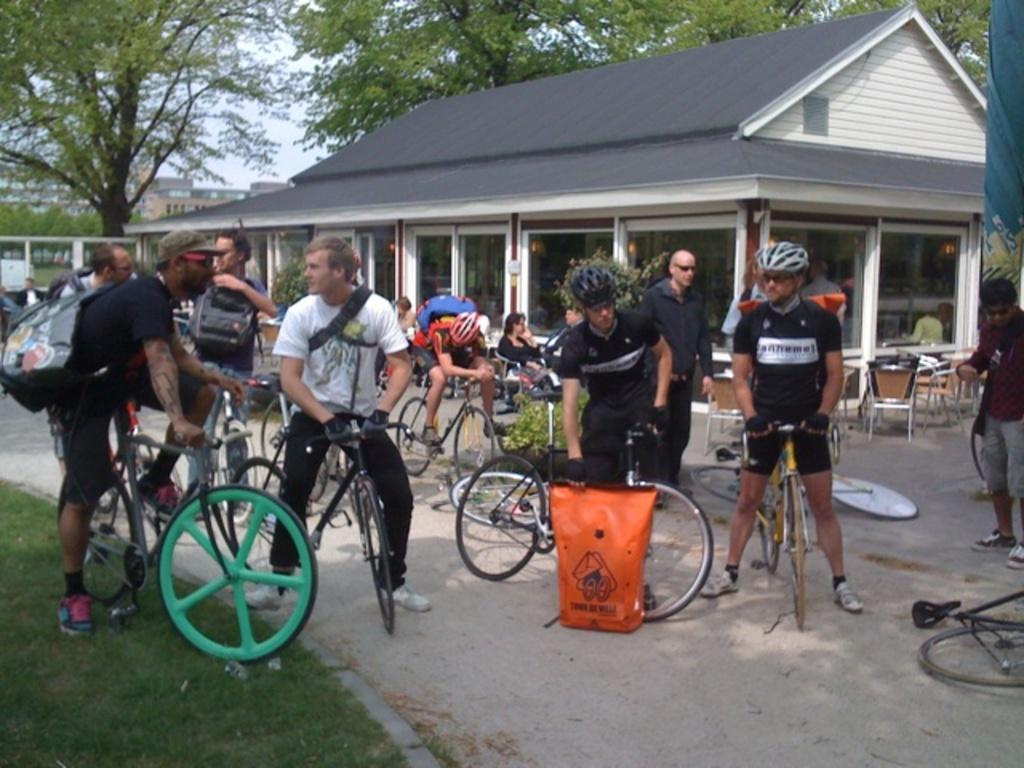What can be seen in the background of the image? In the background of the image, there is a sky, trees, and buildings. What are the persons in the image doing? The persons in the image are riding bicycles on the road. What is the condition of the chairs near the house? The chairs near the house are empty. How would you describe the grass in the image? The grass in the image is fresh and green. Can you see an umbrella being used by a bird in the image? There is no umbrella or bird present in the image. What type of can is being used by the persons with bicycles in the image? There is no can visible in the image; the persons are riding bicycles. 